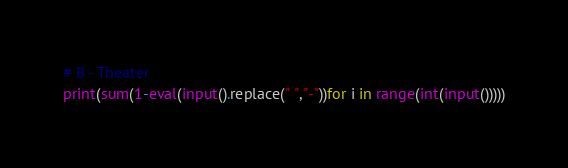<code> <loc_0><loc_0><loc_500><loc_500><_Python_># B - Theater
print(sum(1-eval(input().replace(" ","-"))for i in range(int(input()))))</code> 